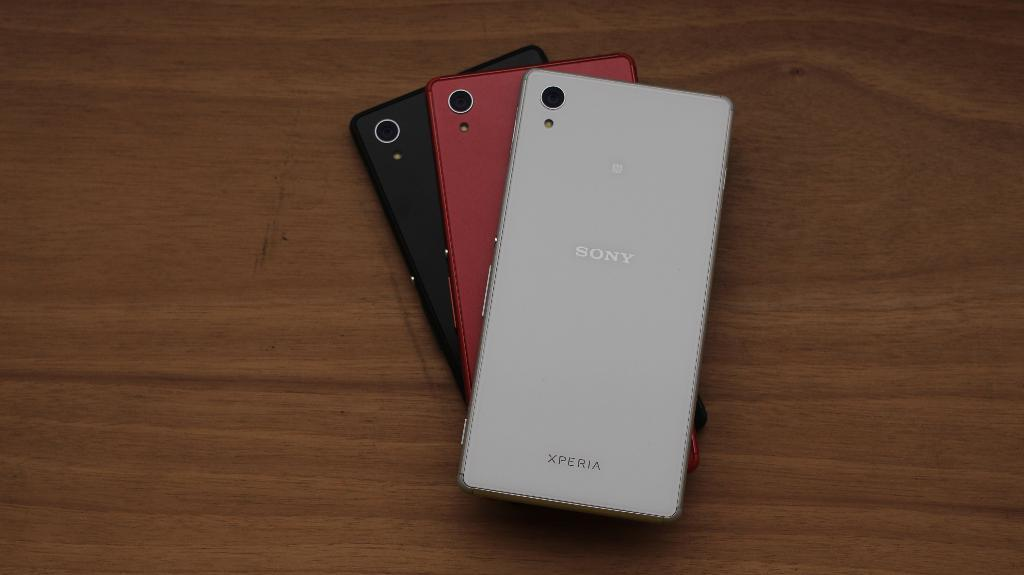<image>
Present a compact description of the photo's key features. the back of three Xperia cell phones with different colors 